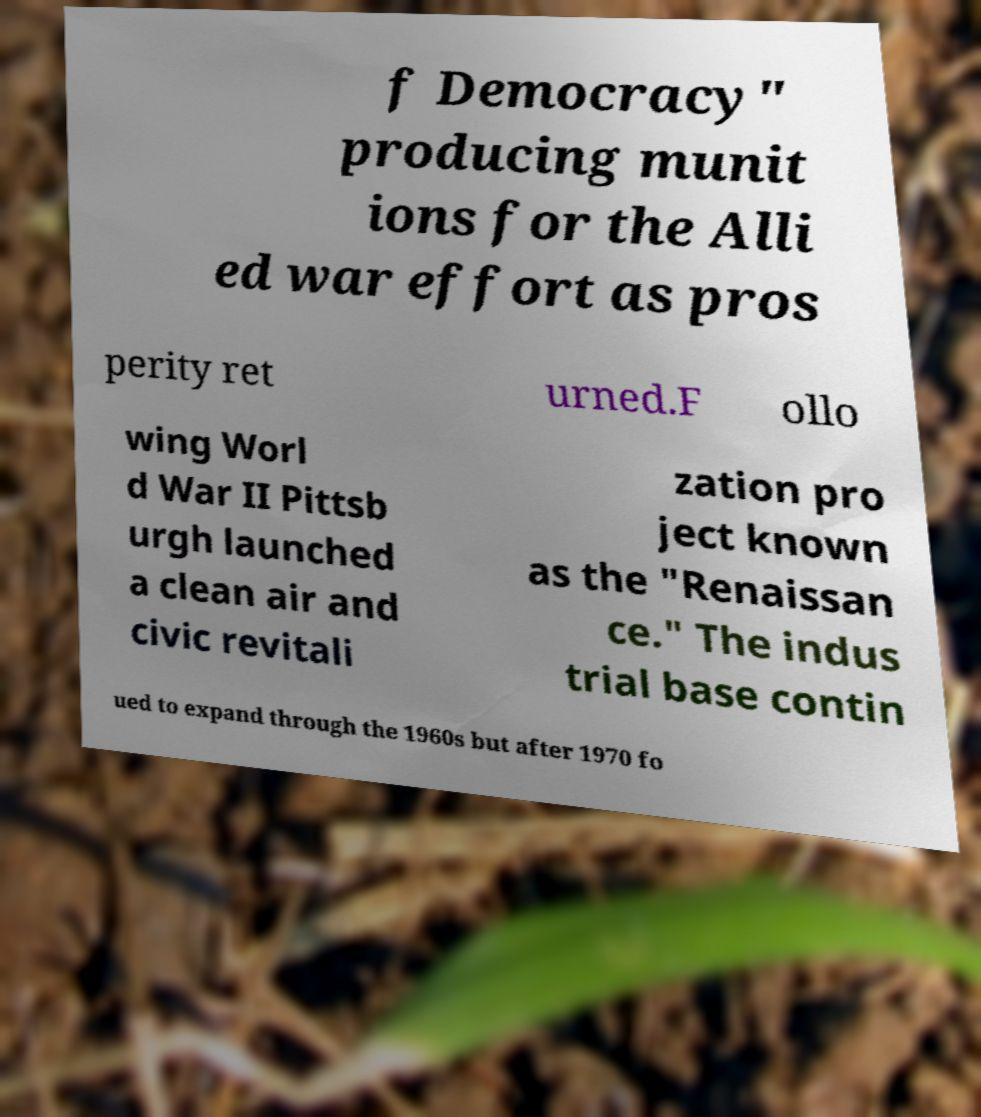Please read and relay the text visible in this image. What does it say? f Democracy" producing munit ions for the Alli ed war effort as pros perity ret urned.F ollo wing Worl d War II Pittsb urgh launched a clean air and civic revitali zation pro ject known as the "Renaissan ce." The indus trial base contin ued to expand through the 1960s but after 1970 fo 